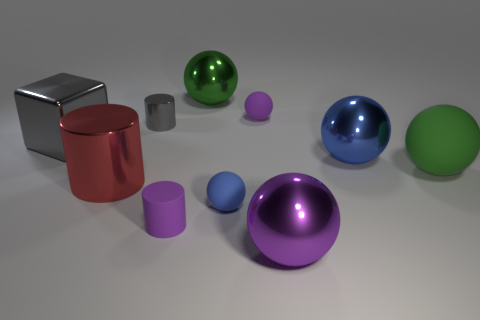What number of other objects are there of the same color as the large cube?
Offer a terse response. 1. What shape is the purple rubber thing behind the tiny purple rubber cylinder?
Keep it short and to the point. Sphere. There is a tiny gray object that is the same material as the large red object; what is its shape?
Your answer should be very brief. Cylinder. How many shiny objects are small balls or small things?
Give a very brief answer. 1. There is a big object in front of the purple rubber object on the left side of the large green metal thing; how many tiny cylinders are right of it?
Ensure brevity in your answer.  0. Does the red metallic cylinder left of the big blue shiny sphere have the same size as the blue object in front of the blue metallic object?
Keep it short and to the point. No. There is another big green thing that is the same shape as the large rubber object; what is its material?
Keep it short and to the point. Metal. What number of large things are either brown things or purple rubber objects?
Offer a terse response. 0. What is the big gray cube made of?
Your response must be concise. Metal. There is a purple thing that is in front of the purple matte ball and behind the purple metallic thing; what is its material?
Your response must be concise. Rubber. 